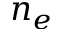Convert formula to latex. <formula><loc_0><loc_0><loc_500><loc_500>n _ { e }</formula> 